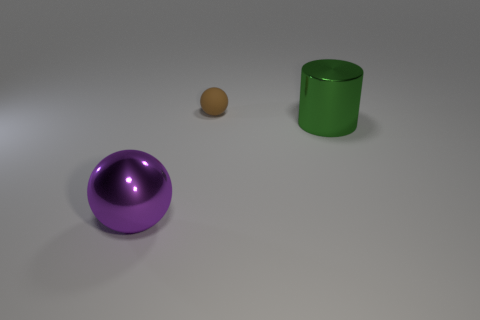What is the shape of the thing that is both in front of the small brown ball and to the right of the purple sphere?
Make the answer very short. Cylinder. Is there a big gray thing that has the same material as the green cylinder?
Give a very brief answer. No. Is the material of the sphere that is in front of the big green cylinder the same as the thing that is behind the cylinder?
Ensure brevity in your answer.  No. Is the number of brown things greater than the number of balls?
Give a very brief answer. No. What color is the large thing that is in front of the large object on the right side of the shiny thing that is to the left of the green metal cylinder?
Your response must be concise. Purple. How many purple balls are to the left of the thing that is to the right of the brown rubber ball?
Keep it short and to the point. 1. Is there a red matte sphere?
Ensure brevity in your answer.  No. How many other objects are there of the same color as the shiny sphere?
Ensure brevity in your answer.  0. Are there fewer purple rubber objects than large purple objects?
Your answer should be very brief. Yes. There is a thing that is in front of the shiny thing that is behind the purple metal object; what shape is it?
Make the answer very short. Sphere. 